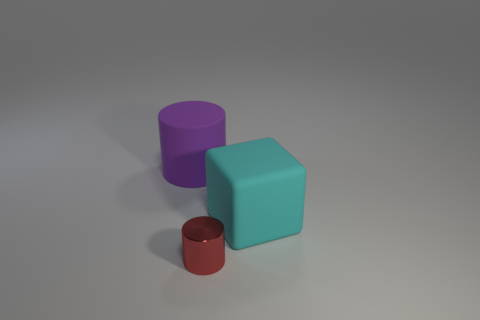Add 1 large rubber cylinders. How many objects exist? 4 Subtract all blocks. How many objects are left? 2 Add 1 cyan metal blocks. How many cyan metal blocks exist? 1 Subtract 1 red cylinders. How many objects are left? 2 Subtract all purple matte cylinders. Subtract all tiny yellow rubber cylinders. How many objects are left? 2 Add 2 tiny red cylinders. How many tiny red cylinders are left? 3 